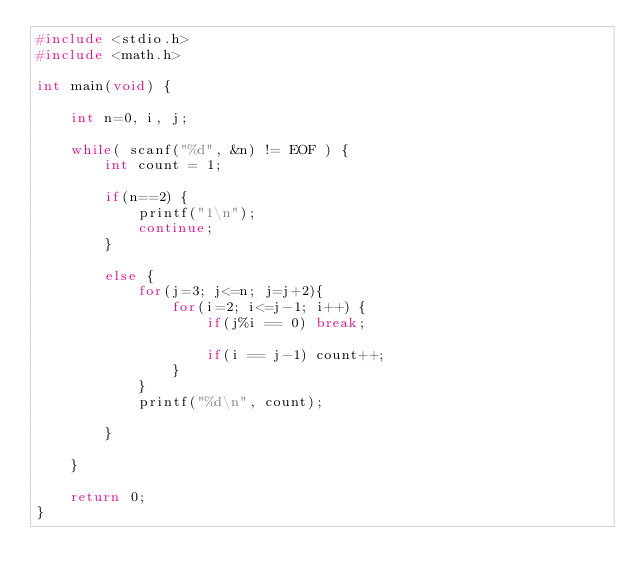<code> <loc_0><loc_0><loc_500><loc_500><_C_>#include <stdio.h>
#include <math.h>

int main(void) {

	int n=0, i, j;
	
	while( scanf("%d", &n) != EOF ) {
		int count = 1;
		
		if(n==2) {
			printf("1\n");
			continue;
		}
		
		else {
			for(j=3; j<=n; j=j+2){
				for(i=2; i<=j-1; i++) {
					if(j%i == 0) break;
				
					if(i == j-1) count++;
				}
			}
			printf("%d\n", count);
			
		}
	
	}
	
	return 0;
}
		</code> 